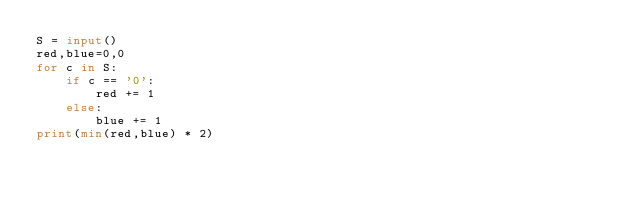<code> <loc_0><loc_0><loc_500><loc_500><_Python_>S = input()
red,blue=0,0
for c in S:
    if c == '0':
        red += 1
    else:
        blue += 1
print(min(red,blue) * 2)</code> 